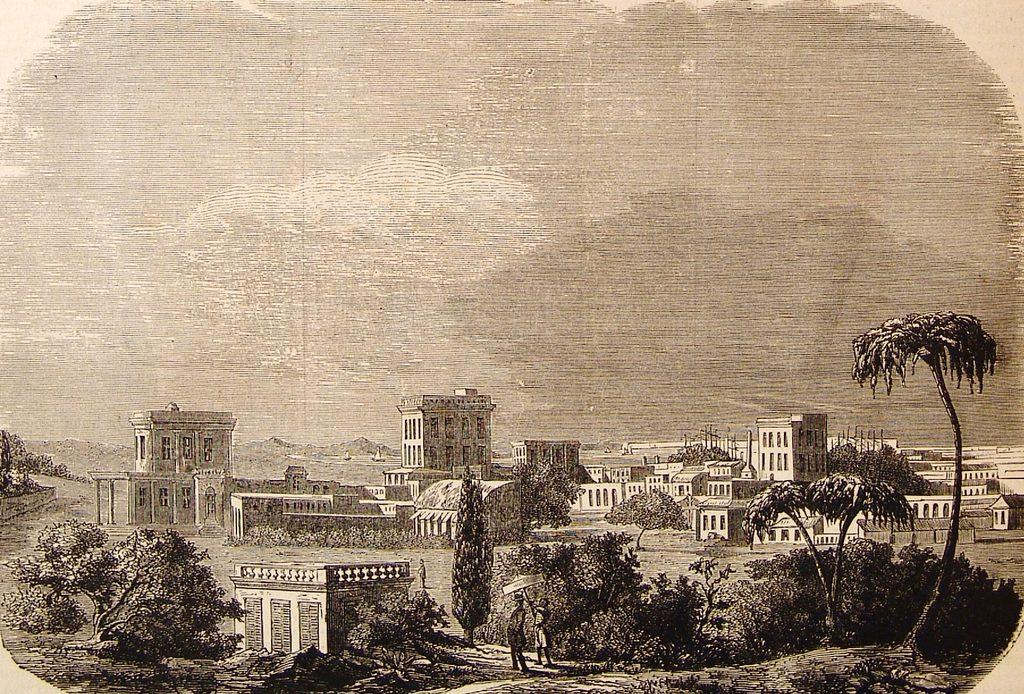What type of vegetation can be seen in the image? There are trees in the image. What structures are visible in the background of the image? There are buildings in the background of the image. What part of the natural environment is visible in the image? The sky is visible in the background of the image. What type of card is being used by the tree in the image? There is no card present in the image, as it features trees and buildings. How many beans can be seen on the tree in the image? There are no beans present in the image, as it features trees and buildings. 